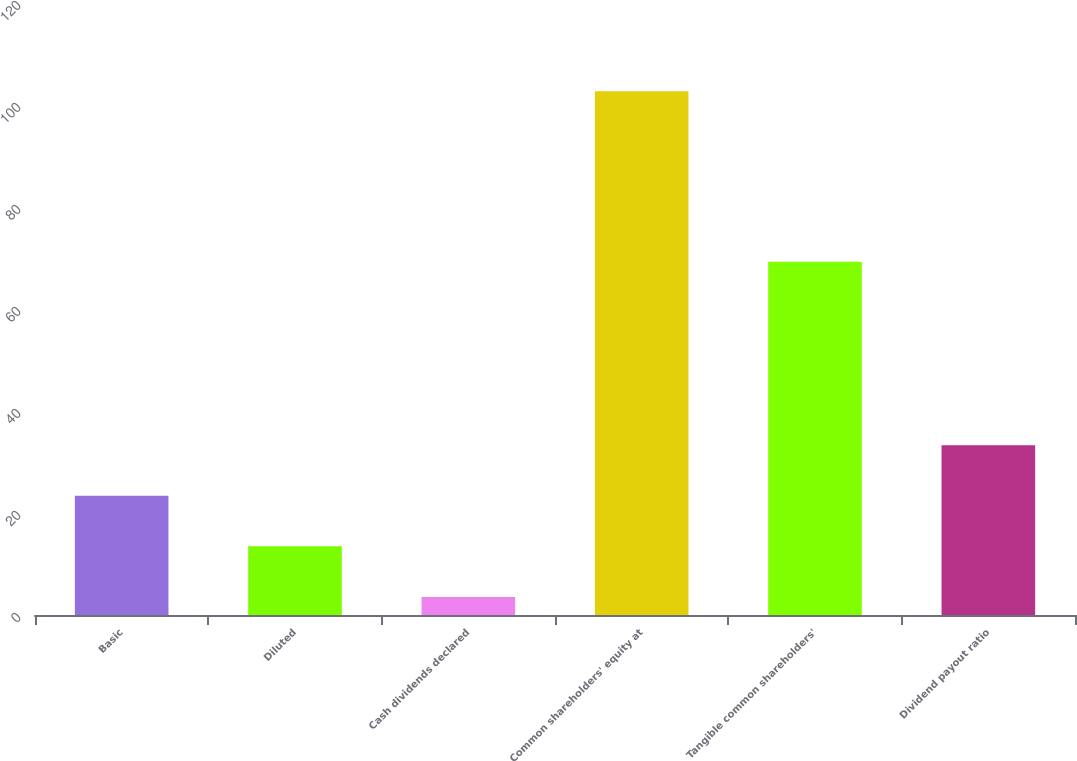Convert chart. <chart><loc_0><loc_0><loc_500><loc_500><bar_chart><fcel>Basic<fcel>Diluted<fcel>Cash dividends declared<fcel>Common shareholders' equity at<fcel>Tangible common shareholders'<fcel>Dividend payout ratio<nl><fcel>23.37<fcel>13.46<fcel>3.55<fcel>102.69<fcel>69.28<fcel>33.28<nl></chart> 